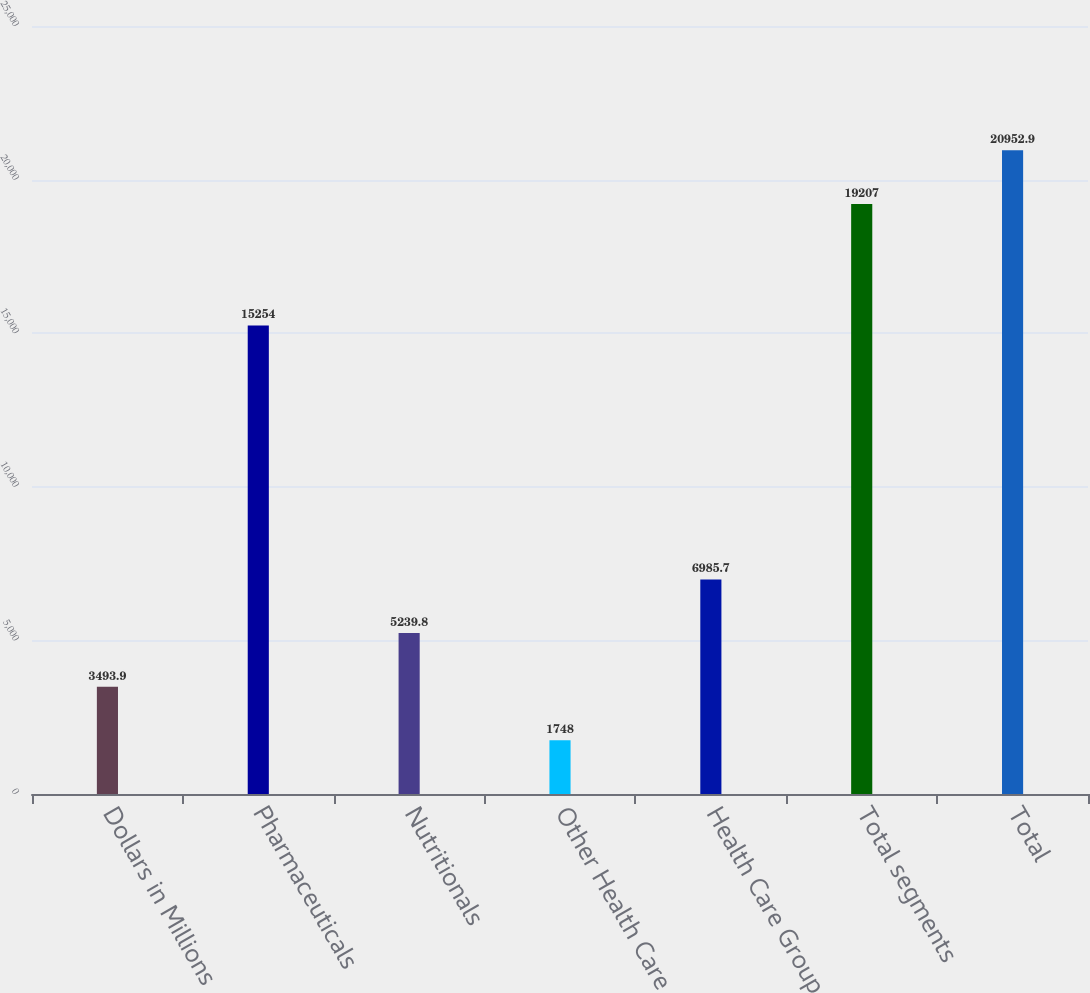Convert chart to OTSL. <chart><loc_0><loc_0><loc_500><loc_500><bar_chart><fcel>Dollars in Millions<fcel>Pharmaceuticals<fcel>Nutritionals<fcel>Other Health Care<fcel>Health Care Group<fcel>Total segments<fcel>Total<nl><fcel>3493.9<fcel>15254<fcel>5239.8<fcel>1748<fcel>6985.7<fcel>19207<fcel>20952.9<nl></chart> 